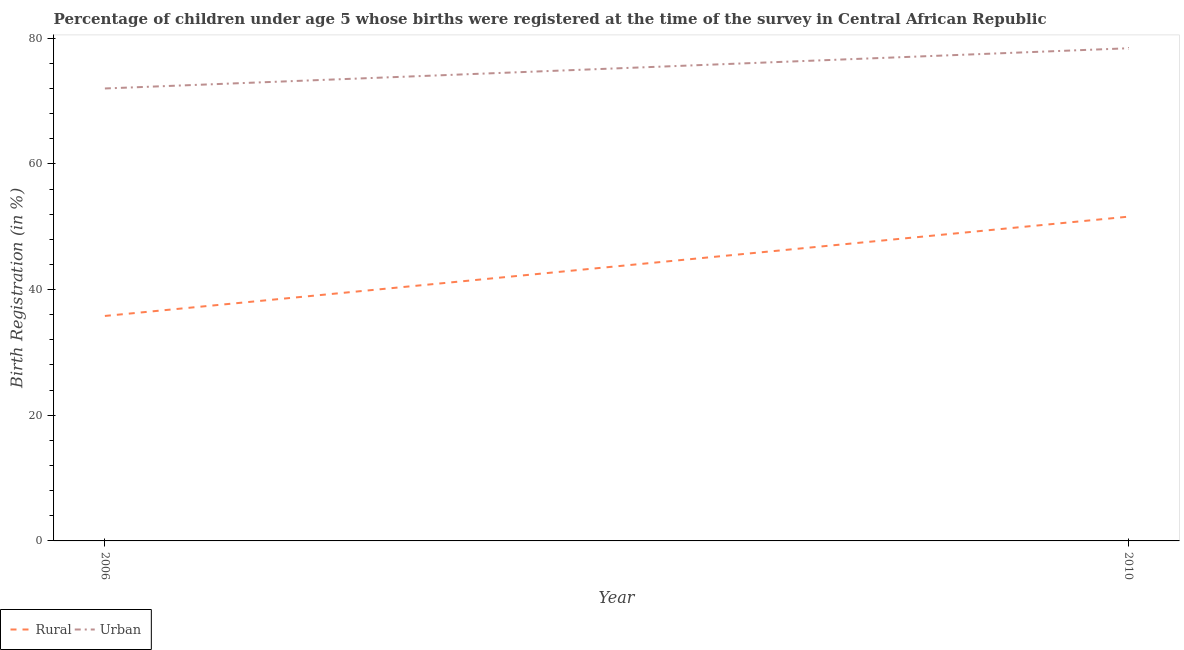How many different coloured lines are there?
Keep it short and to the point. 2. Is the number of lines equal to the number of legend labels?
Ensure brevity in your answer.  Yes. What is the rural birth registration in 2006?
Offer a terse response. 35.8. Across all years, what is the maximum urban birth registration?
Your response must be concise. 78.4. In which year was the urban birth registration maximum?
Offer a very short reply. 2010. What is the total rural birth registration in the graph?
Provide a short and direct response. 87.4. What is the difference between the urban birth registration in 2006 and that in 2010?
Your answer should be very brief. -6.4. What is the difference between the urban birth registration in 2010 and the rural birth registration in 2006?
Offer a very short reply. 42.6. What is the average rural birth registration per year?
Your response must be concise. 43.7. In the year 2006, what is the difference between the urban birth registration and rural birth registration?
Provide a short and direct response. 36.2. In how many years, is the rural birth registration greater than 8 %?
Your response must be concise. 2. What is the ratio of the urban birth registration in 2006 to that in 2010?
Keep it short and to the point. 0.92. Is the urban birth registration in 2006 less than that in 2010?
Provide a short and direct response. Yes. In how many years, is the rural birth registration greater than the average rural birth registration taken over all years?
Your answer should be compact. 1. Is the urban birth registration strictly greater than the rural birth registration over the years?
Your answer should be compact. Yes. Is the urban birth registration strictly less than the rural birth registration over the years?
Offer a very short reply. No. What is the difference between two consecutive major ticks on the Y-axis?
Your answer should be compact. 20. Are the values on the major ticks of Y-axis written in scientific E-notation?
Make the answer very short. No. Does the graph contain any zero values?
Your answer should be very brief. No. Where does the legend appear in the graph?
Keep it short and to the point. Bottom left. What is the title of the graph?
Offer a very short reply. Percentage of children under age 5 whose births were registered at the time of the survey in Central African Republic. Does "Age 65(female)" appear as one of the legend labels in the graph?
Offer a very short reply. No. What is the label or title of the Y-axis?
Give a very brief answer. Birth Registration (in %). What is the Birth Registration (in %) of Rural in 2006?
Give a very brief answer. 35.8. What is the Birth Registration (in %) in Rural in 2010?
Provide a succinct answer. 51.6. What is the Birth Registration (in %) of Urban in 2010?
Your response must be concise. 78.4. Across all years, what is the maximum Birth Registration (in %) in Rural?
Provide a short and direct response. 51.6. Across all years, what is the maximum Birth Registration (in %) in Urban?
Provide a short and direct response. 78.4. Across all years, what is the minimum Birth Registration (in %) of Rural?
Keep it short and to the point. 35.8. Across all years, what is the minimum Birth Registration (in %) in Urban?
Offer a very short reply. 72. What is the total Birth Registration (in %) of Rural in the graph?
Your response must be concise. 87.4. What is the total Birth Registration (in %) of Urban in the graph?
Provide a succinct answer. 150.4. What is the difference between the Birth Registration (in %) of Rural in 2006 and that in 2010?
Your answer should be very brief. -15.8. What is the difference between the Birth Registration (in %) in Rural in 2006 and the Birth Registration (in %) in Urban in 2010?
Offer a terse response. -42.6. What is the average Birth Registration (in %) of Rural per year?
Make the answer very short. 43.7. What is the average Birth Registration (in %) of Urban per year?
Keep it short and to the point. 75.2. In the year 2006, what is the difference between the Birth Registration (in %) of Rural and Birth Registration (in %) of Urban?
Give a very brief answer. -36.2. In the year 2010, what is the difference between the Birth Registration (in %) in Rural and Birth Registration (in %) in Urban?
Ensure brevity in your answer.  -26.8. What is the ratio of the Birth Registration (in %) of Rural in 2006 to that in 2010?
Keep it short and to the point. 0.69. What is the ratio of the Birth Registration (in %) in Urban in 2006 to that in 2010?
Make the answer very short. 0.92. 